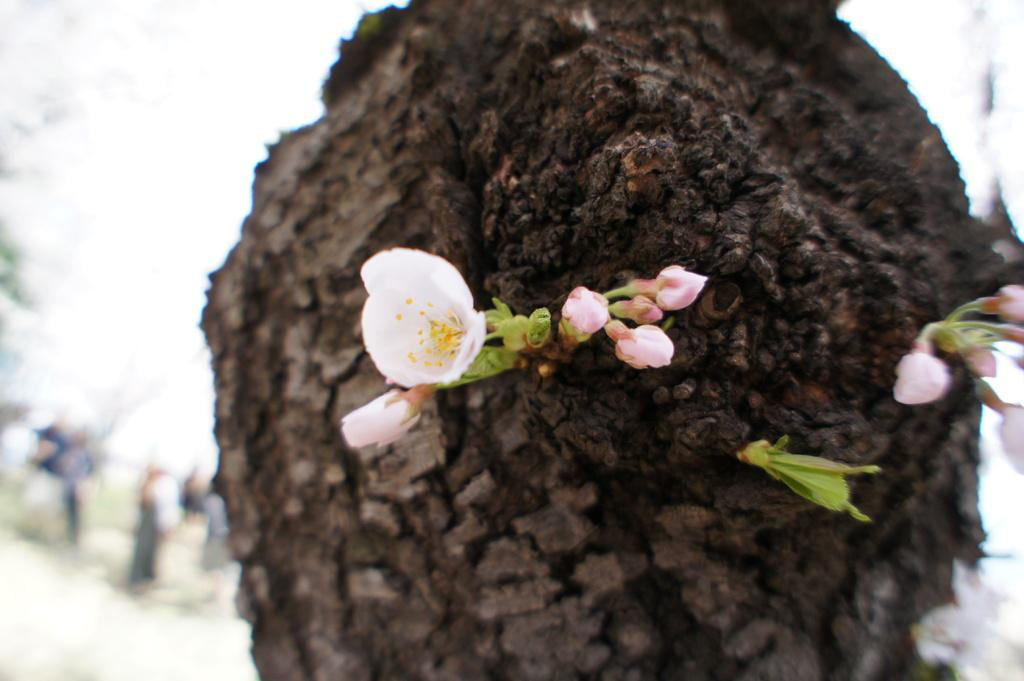What is the main subject of the image? The main subject of the image is a tree stem. What other elements can be seen in the image? There are flowers visible in the image. Can you describe the background of the image? The background of the image is blurred. What type of bike can be seen leaning against the tree stem in the image? There is no bike present in the image; it only features a tree stem and flowers. What kind of leather material is visible on the record in the image? There is no record or leather material present in the image. 